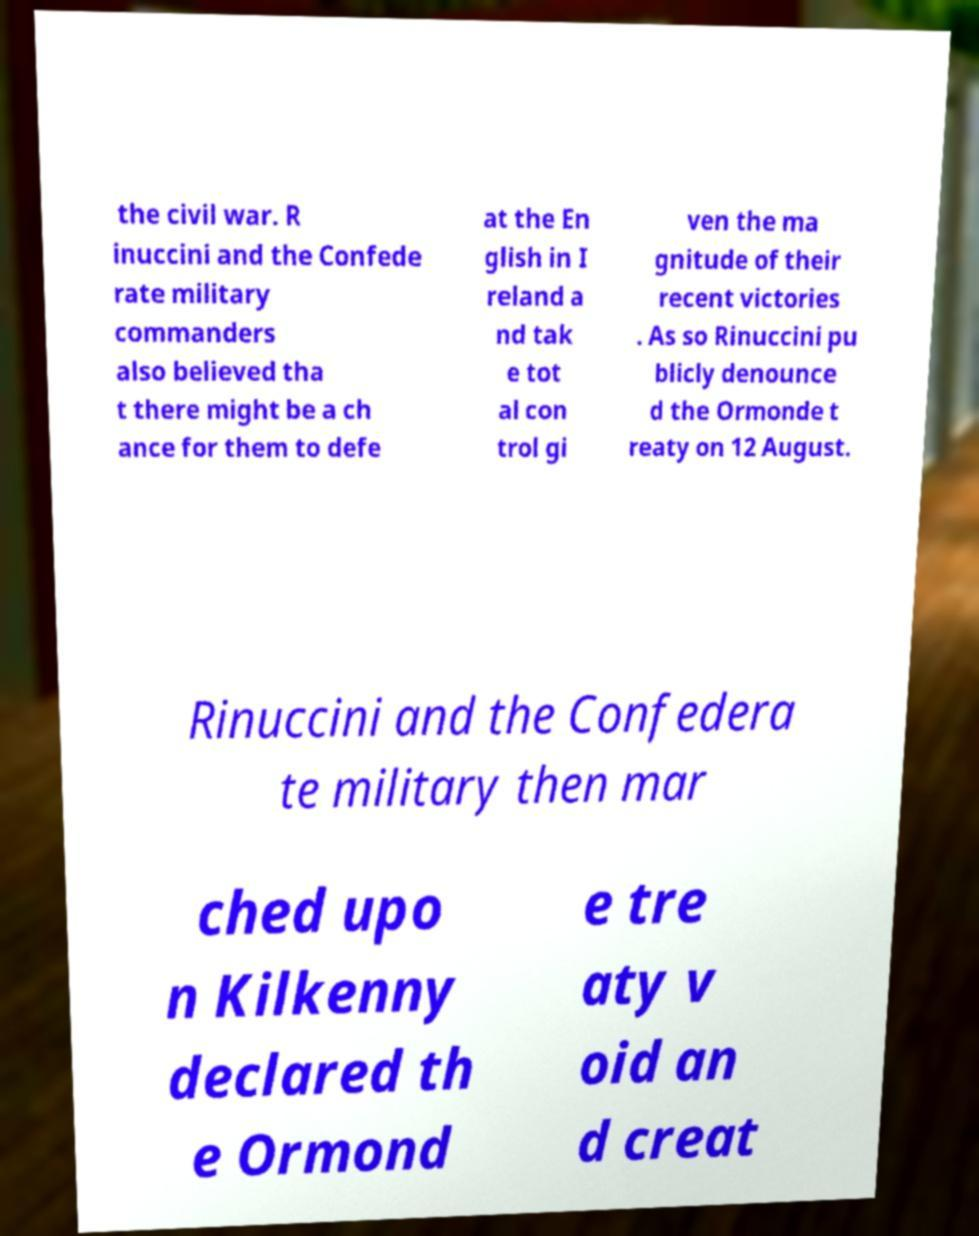Can you read and provide the text displayed in the image?This photo seems to have some interesting text. Can you extract and type it out for me? the civil war. R inuccini and the Confede rate military commanders also believed tha t there might be a ch ance for them to defe at the En glish in I reland a nd tak e tot al con trol gi ven the ma gnitude of their recent victories . As so Rinuccini pu blicly denounce d the Ormonde t reaty on 12 August. Rinuccini and the Confedera te military then mar ched upo n Kilkenny declared th e Ormond e tre aty v oid an d creat 